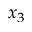Convert formula to latex. <formula><loc_0><loc_0><loc_500><loc_500>x _ { 3 }</formula> 